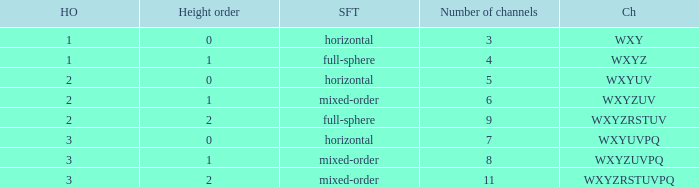In a mixed-order soundfield with a height order of 1, which channels are included? WXYZUV, WXYZUVPQ. 